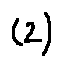Convert formula to latex. <formula><loc_0><loc_0><loc_500><loc_500>( 2 )</formula> 